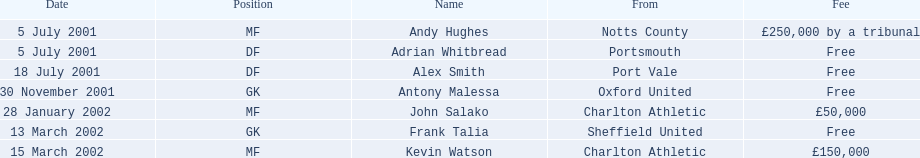What is the total number of free fees? 4. 